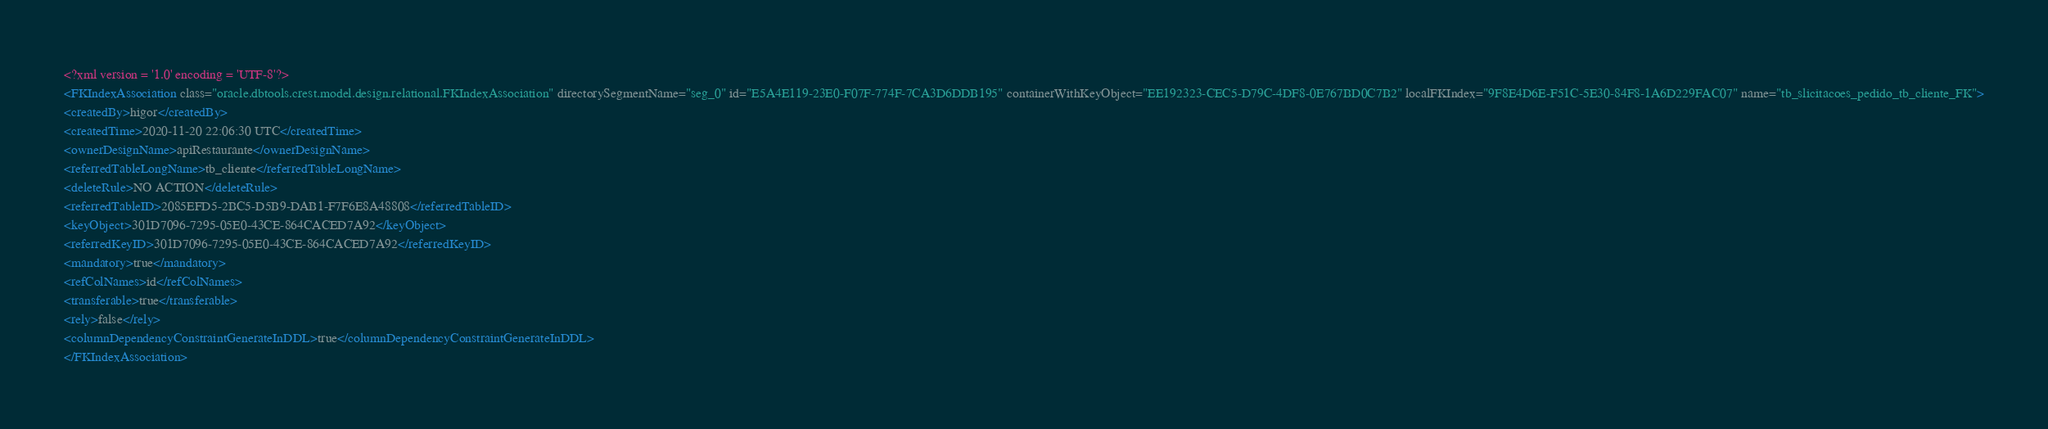Convert code to text. <code><loc_0><loc_0><loc_500><loc_500><_XML_><?xml version = '1.0' encoding = 'UTF-8'?>
<FKIndexAssociation class="oracle.dbtools.crest.model.design.relational.FKIndexAssociation" directorySegmentName="seg_0" id="E5A4E119-23E0-F07F-774F-7CA3D6DDB195" containerWithKeyObject="EE192323-CEC5-D79C-4DF8-0E767BD0C7B2" localFKIndex="9F8E4D6E-F51C-5E30-84F8-1A6D229FAC07" name="tb_slicitacoes_pedido_tb_cliente_FK">
<createdBy>higor</createdBy>
<createdTime>2020-11-20 22:06:30 UTC</createdTime>
<ownerDesignName>apiRestaurante</ownerDesignName>
<referredTableLongName>tb_cliente</referredTableLongName>
<deleteRule>NO ACTION</deleteRule>
<referredTableID>2085EFD5-2BC5-D5B9-DAB1-F7F6E8A48808</referredTableID>
<keyObject>301D7096-7295-05E0-43CE-864CACED7A92</keyObject>
<referredKeyID>301D7096-7295-05E0-43CE-864CACED7A92</referredKeyID>
<mandatory>true</mandatory>
<refColNames>id</refColNames>
<transferable>true</transferable>
<rely>false</rely>
<columnDependencyConstraintGenerateInDDL>true</columnDependencyConstraintGenerateInDDL>
</FKIndexAssociation></code> 